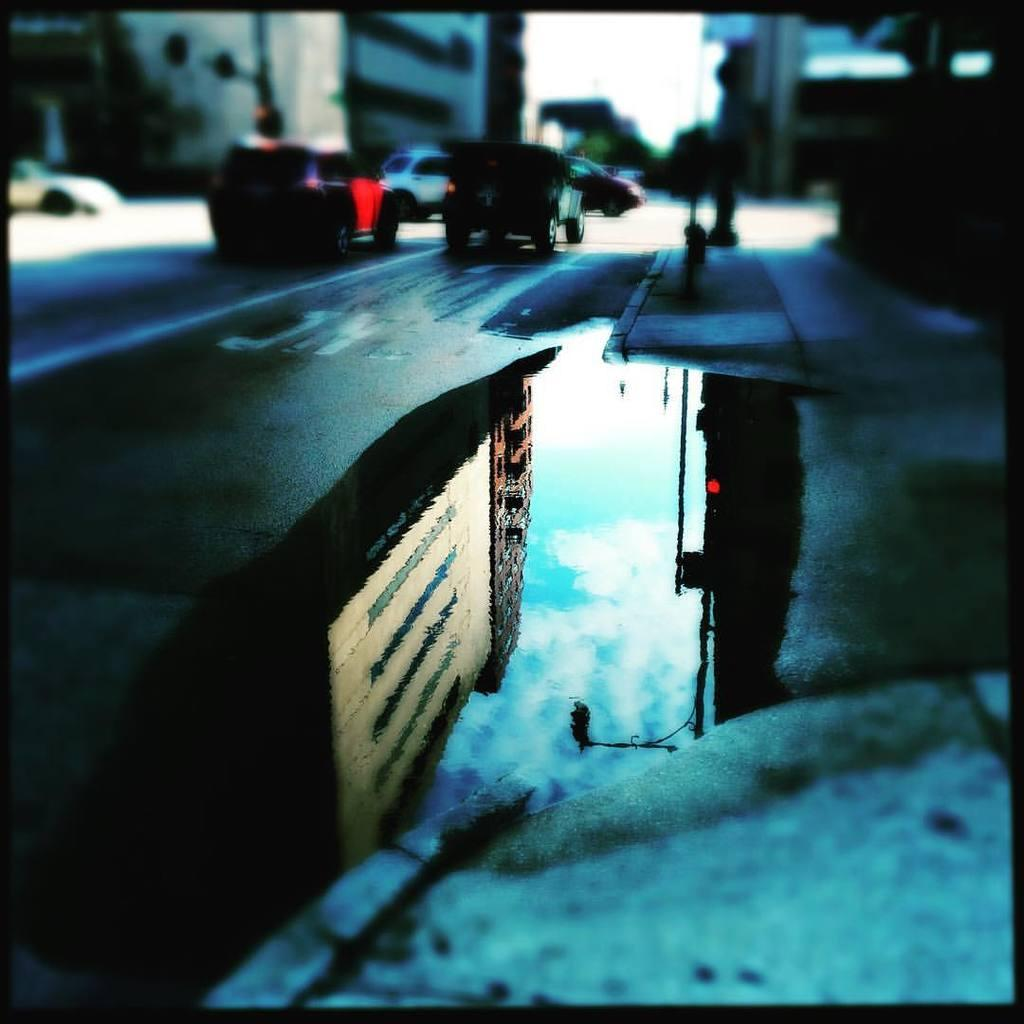What is the main subject of the image? The image depicts a road. Can you describe any other elements in the image? There is water visible in the image. What is happening on the road in the image? There are vehicles moving in the image. What type of yoke is being used to wash the vehicles in the image? There is no yoke or washing of vehicles present in the image. 